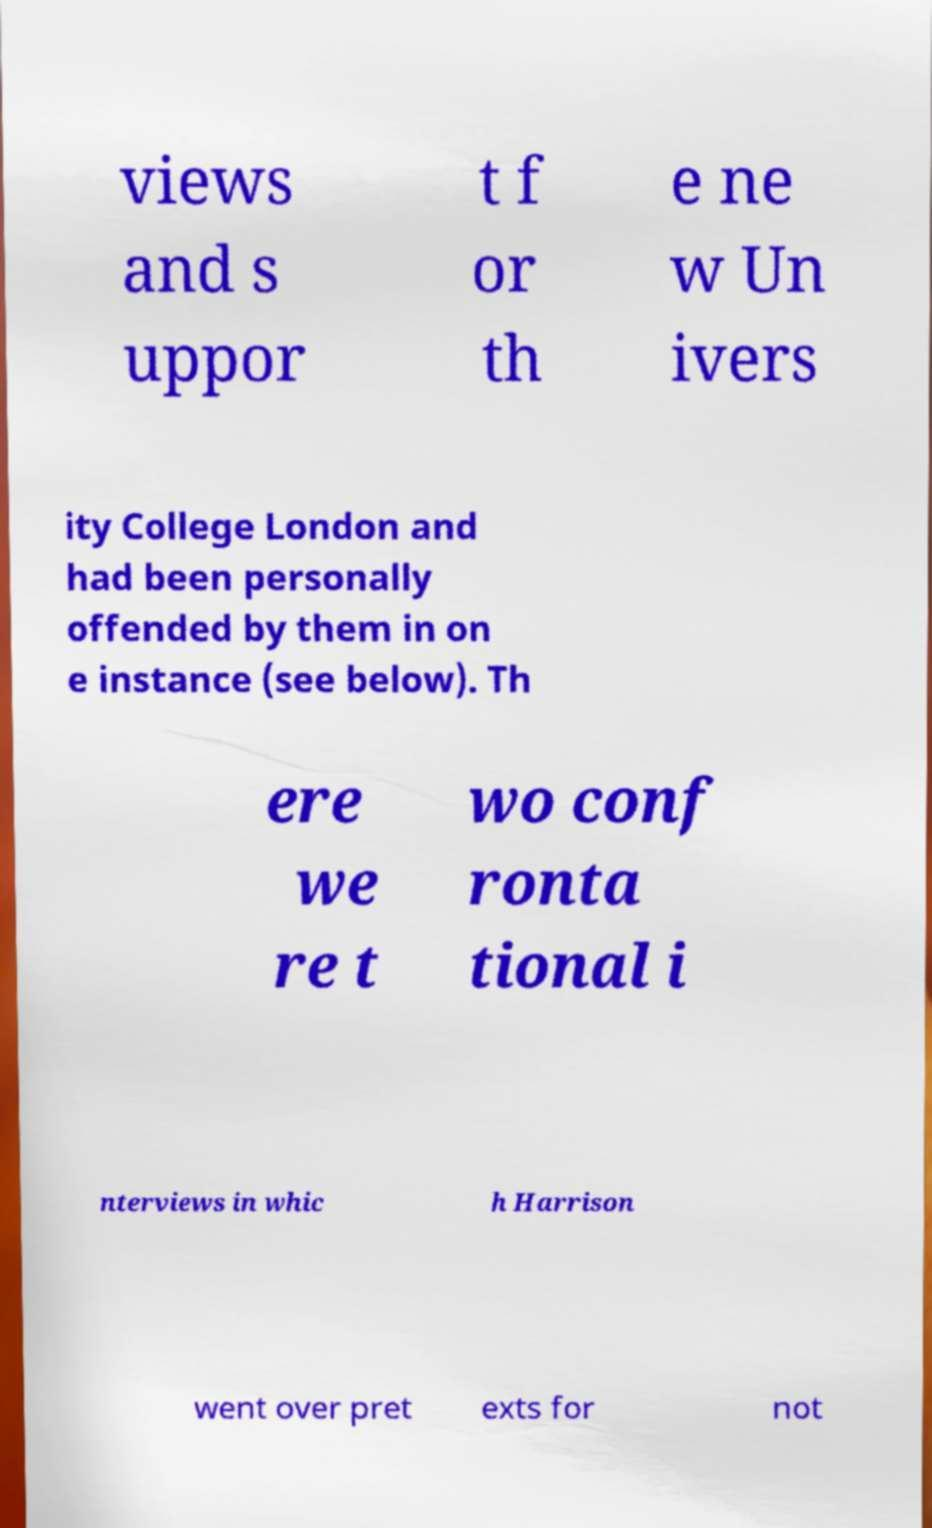Can you read and provide the text displayed in the image?This photo seems to have some interesting text. Can you extract and type it out for me? views and s uppor t f or th e ne w Un ivers ity College London and had been personally offended by them in on e instance (see below). Th ere we re t wo conf ronta tional i nterviews in whic h Harrison went over pret exts for not 